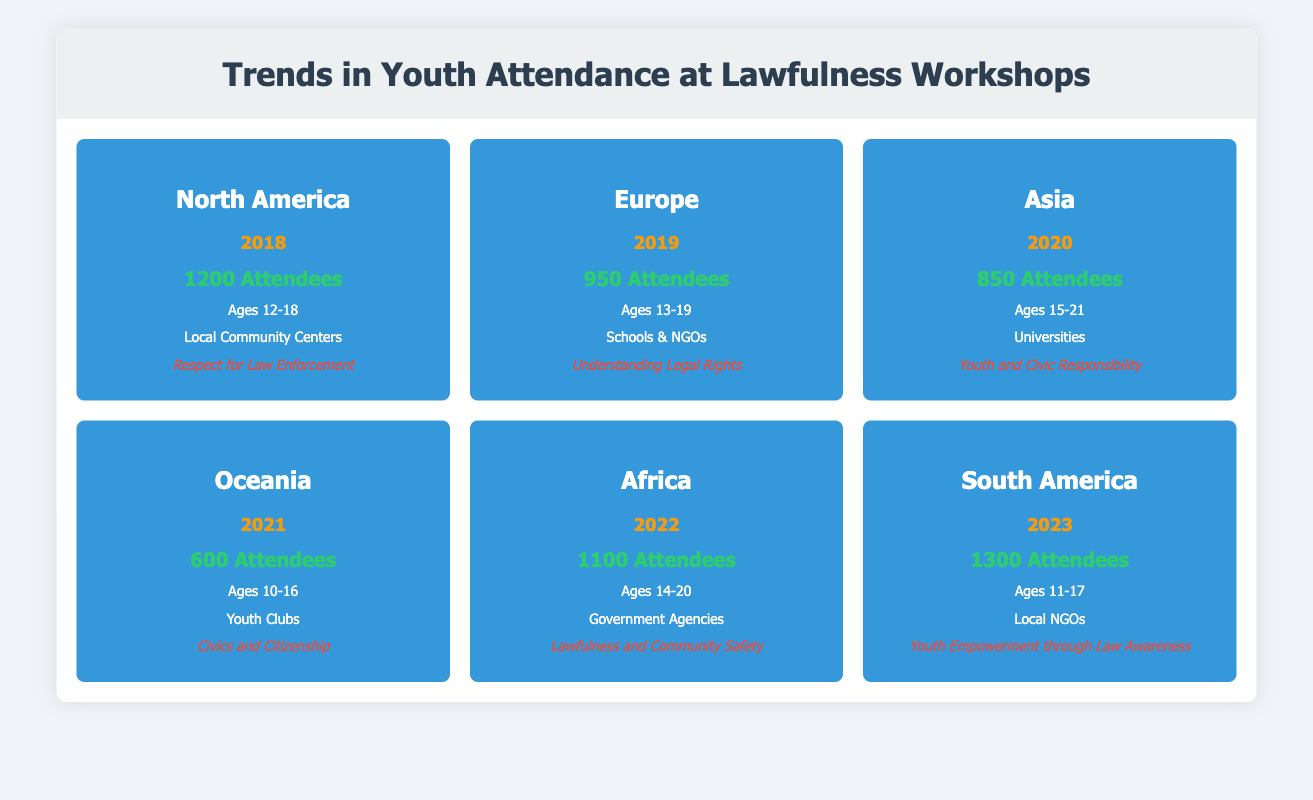What was the total attendance for lawfulness workshops in North America in 2018? According to the table, the attendance for lawfulness workshops in North America for the year 2018 is explicitly listed as 1200 attendees.
Answer: 1200 In which year did Oceania have the lowest youth attendance for lawfulness workshops? The table shows that the year 2021 has the lowest attendance listed for Oceania, with a total of 600 attendees.
Answer: 2021 How many more attendees were there in South America in 2023 compared to Asia in 2020? The attendance in South America in 2023 is 1300, while the attendance in Asia in 2020 is 850. To find the difference, subtract 850 from 1300, resulting in 450 more attendees.
Answer: 450 Is the focus topic in Europe in 2019 related to the understanding of legal rights? The table indicates that the focus topic for Europe in 2019 is "Understanding Legal Rights," which confirms that it is indeed related.
Answer: Yes What is the average total attendance for the workshops from 2018 to 2022? To find the average, sum the total attendance figures for the years 2018 (1200), 2019 (950), 2020 (850), 2021 (600), and 2022 (1100): 1200 + 950 + 850 + 600 + 1100 = 4750. There are 5 years, so dividing 4750 by 5 gives an average of 950 attendees.
Answer: 950 Which region had the highest attendance from 2018 to 2023? The table shows that South America had the highest attendance with 1300 attendees in 2023, compared to other regions’ attendance figures in the corresponding years.
Answer: South America How many years had a total attendance below 1000? Looking at each year’s total attendance, 2019 (950), 2020 (850), and 2021 (600) are below 1000. This totals to 3 years.
Answer: 3 What trend can be observed in the total attendance from 2018 to 2023? Analyzing the data, total attendance started at 1200 in 2018, dipped to 600 in 2021, and then rose to 1300 in 2023. This indicates a fluctuation overall, but a significant increase in 2023 compared to the previous years.
Answer: Upward trend post-2021 